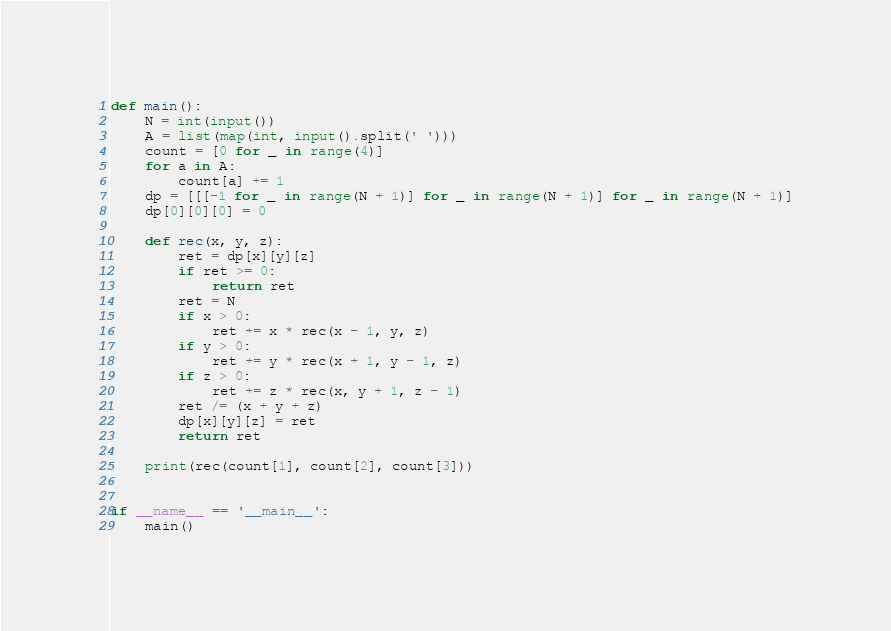Convert code to text. <code><loc_0><loc_0><loc_500><loc_500><_Python_>def main():
    N = int(input())
    A = list(map(int, input().split(' ')))
    count = [0 for _ in range(4)]
    for a in A:
        count[a] += 1
    dp = [[[-1 for _ in range(N + 1)] for _ in range(N + 1)] for _ in range(N + 1)]
    dp[0][0][0] = 0

    def rec(x, y, z):
        ret = dp[x][y][z]
        if ret >= 0:
            return ret
        ret = N
        if x > 0:
            ret += x * rec(x - 1, y, z)
        if y > 0:
            ret += y * rec(x + 1, y - 1, z)
        if z > 0:
            ret += z * rec(x, y + 1, z - 1)
        ret /= (x + y + z)
        dp[x][y][z] = ret
        return ret

    print(rec(count[1], count[2], count[3]))


if __name__ == '__main__':
    main()</code> 